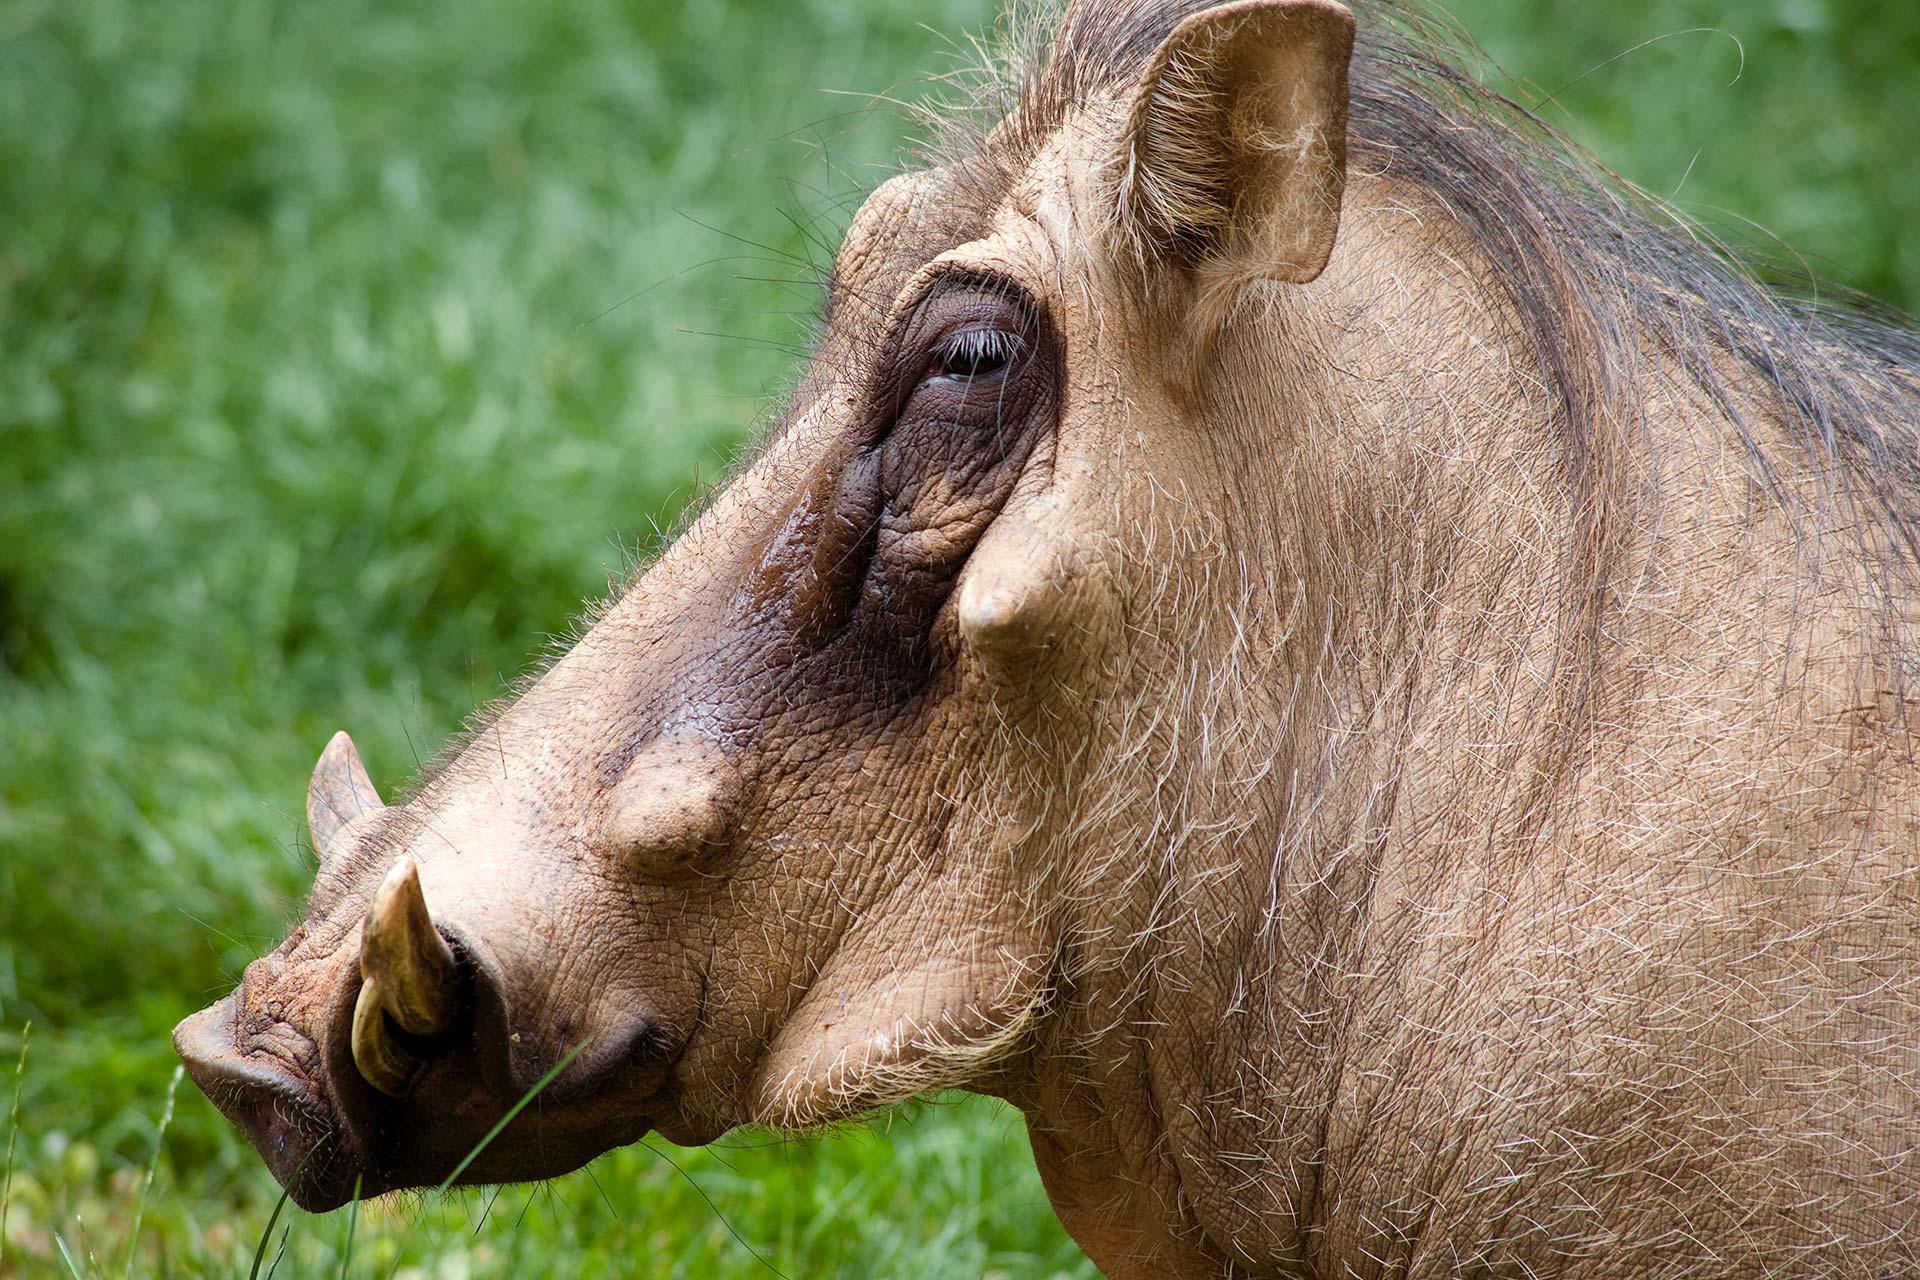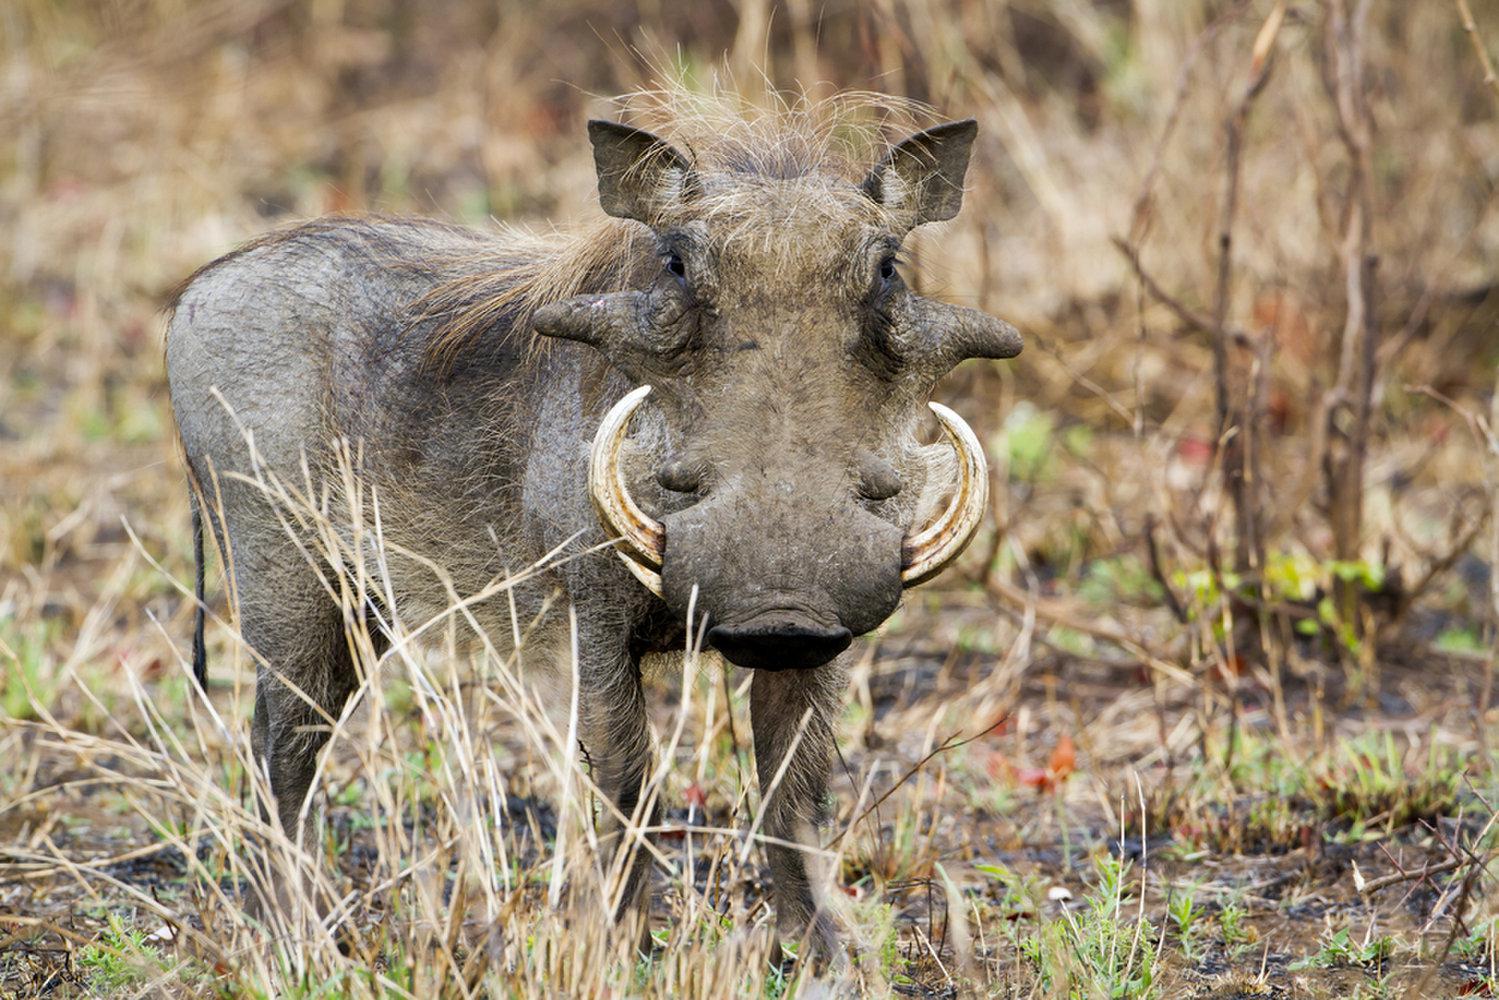The first image is the image on the left, the second image is the image on the right. Considering the images on both sides, is "An image contains both juvenile and adult warthogs, and features small animals standing by a taller animal." valid? Answer yes or no. No. The first image is the image on the left, the second image is the image on the right. Examine the images to the left and right. Is the description "There are more than one animals in on of the images." accurate? Answer yes or no. No. 